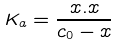Convert formula to latex. <formula><loc_0><loc_0><loc_500><loc_500>K _ { a } = \frac { x . x } { c _ { 0 } - x }</formula> 